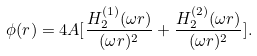<formula> <loc_0><loc_0><loc_500><loc_500>\phi ( r ) = 4 A [ \frac { H _ { 2 } ^ { ( 1 ) } ( \omega r ) } { ( \omega r ) ^ { 2 } } + \frac { H _ { 2 } ^ { ( 2 ) } ( \omega r ) } { ( \omega r ) ^ { 2 } } ] .</formula> 